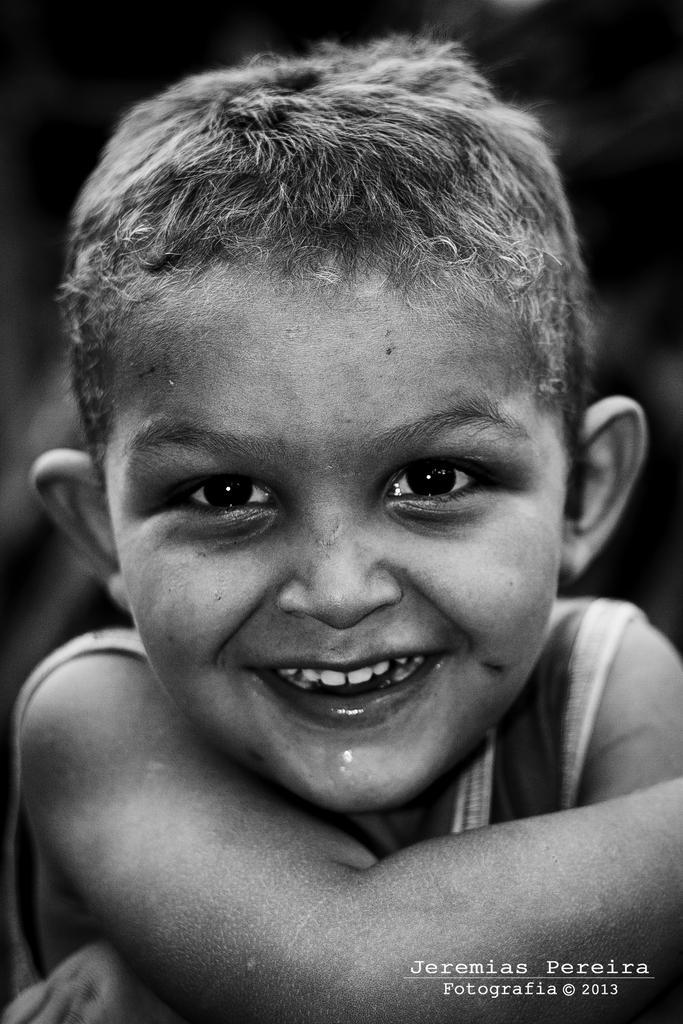Describe this image in one or two sentences. It is a black and white image. In this image there is a boy having a smile on his face. There are some text and numbers at the bottom of the image. 